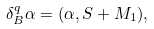Convert formula to latex. <formula><loc_0><loc_0><loc_500><loc_500>\delta _ { B } ^ { q } \alpha = ( \alpha , S + M _ { 1 } ) ,</formula> 